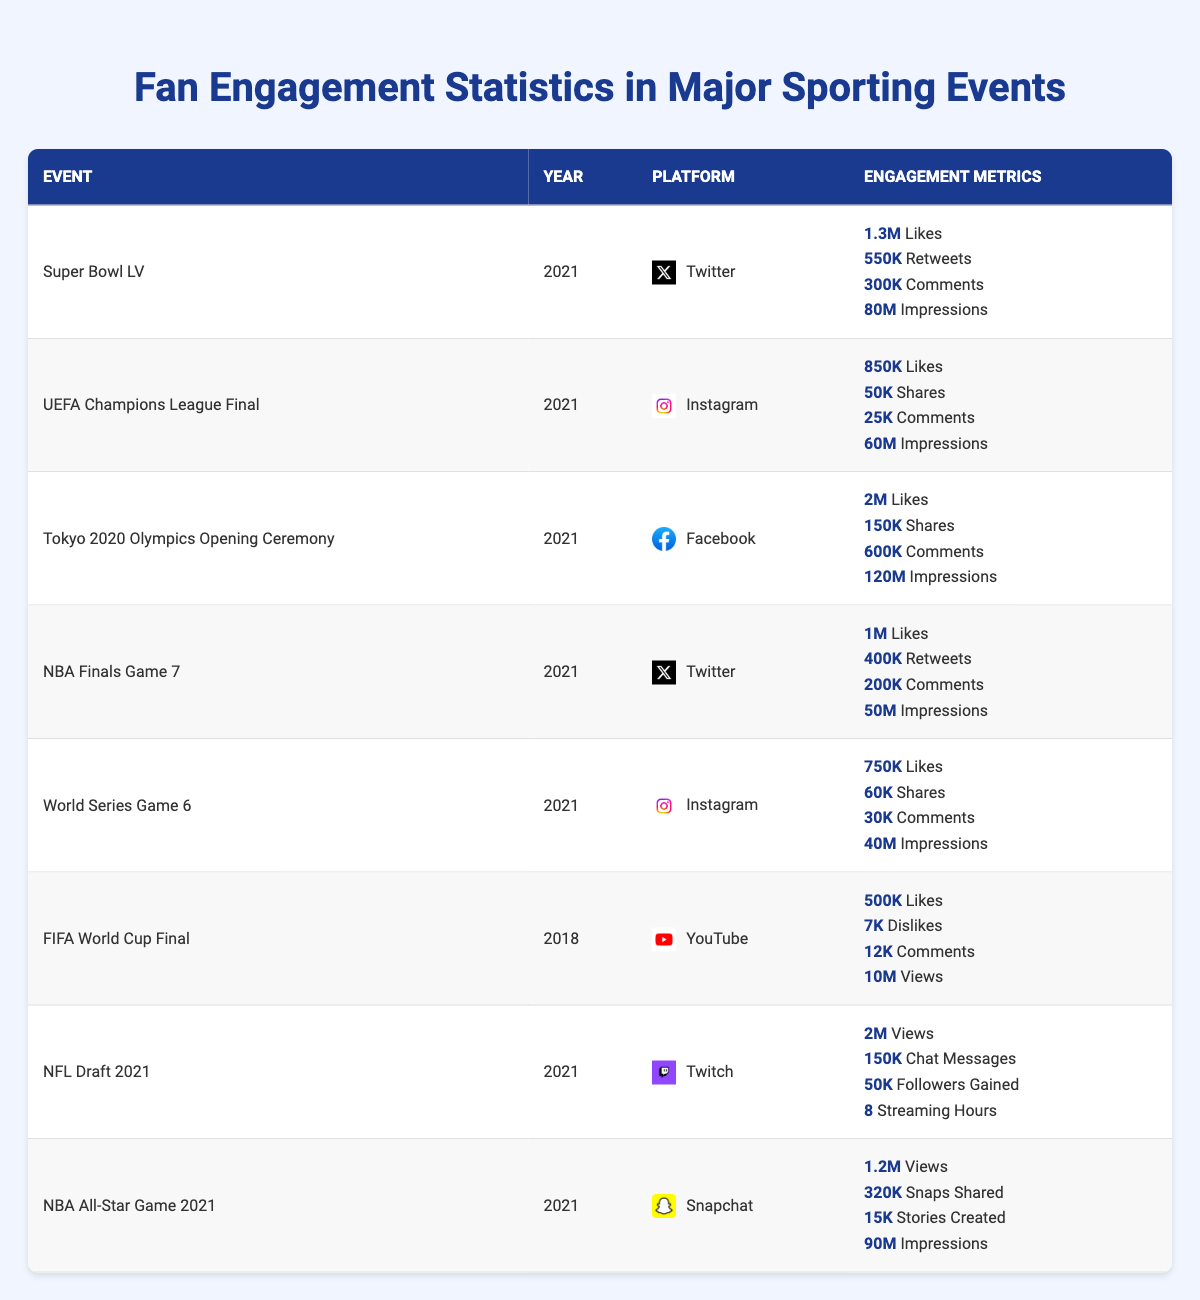What is the total number of likes for the Super Bowl LV on Twitter? The table indicates that the Super Bowl LV received 1,300,000 likes.
Answer: 1,300,000 Which event had the highest impressions on Facebook? The Tokyo 2020 Olympics Opening Ceremony had 120,000,000 impressions, which is higher than any other event in the table.
Answer: Tokyo 2020 Olympics Opening Ceremony How many shares did the UEFA Champions League Final receive on Instagram? According to the table, the UEFA Champions League Final received 50,000 shares.
Answer: 50,000 What is the total number of comments for all events listed on Instagram? For Instagram, the comments are as follows: 25,000 (Champions League Final) + 30,000 (World Series Game 6) = 55,000 comments.
Answer: 55,000 Which platform had more total views, YouTube for the FIFA World Cup Final or Twitch for the NFL Draft 2021? YouTube had 10,000,000 views and Twitch had 2,000,000 views. Therefore, YouTube had more views.
Answer: YouTube Did the NBA Finals Game 7 have more likes than the World Series Game 6? The NBA Finals Game 7 had 1,000,000 likes, while the World Series Game 6 had 750,000 likes. Since 1,000,000 is greater than 750,000, the answer is yes.
Answer: Yes What is the average number of comments for all events listed in the table? The total comments are: 300,000 (Super Bowl LV) + 25,000 (Champions League Final) + 600,000 (Tokyo 2020) + 200,000 (NBA Finals) + 30,000 (World Series) + 12,000 (FIFA World Cup Final) + 150,000 (NFL Draft) + 15,000 (NBA All-Star) = 1,432,000. There are 8 events, so the average is 1,432,000 / 8 = 179,000.
Answer: 179,000 Which event resulted in the most chat messages on Twitch? The NFL Draft 2021 had 150,000 chat messages, which is the only entry for Twitch in the table.
Answer: NFL Draft 2021 How many total followers were gained during the NFL Draft 2021 on Twitch? The table states that 50,000 followers were gained during the NFL Draft 2021.
Answer: 50,000 Is it true that the NBA All-Star Game 2021 received more snaps shared than the UEFA Champions League Final received likes? The NBA All-Star Game 2021 received 320,000 snaps shared while the UEFA Champions League Final received 850,000 likes. Since 320,000 is less than 850,000, the answer is false.
Answer: No What was the difference in likes between the Tokyo 2020 Olympics Opening Ceremony and the Super Bowl LV? The Tokyo 2020 Olympics had 2,000,000 likes and the Super Bowl LV had 1,300,000 likes. The difference is 2,000,000 - 1,300,000 = 700,000.
Answer: 700,000 